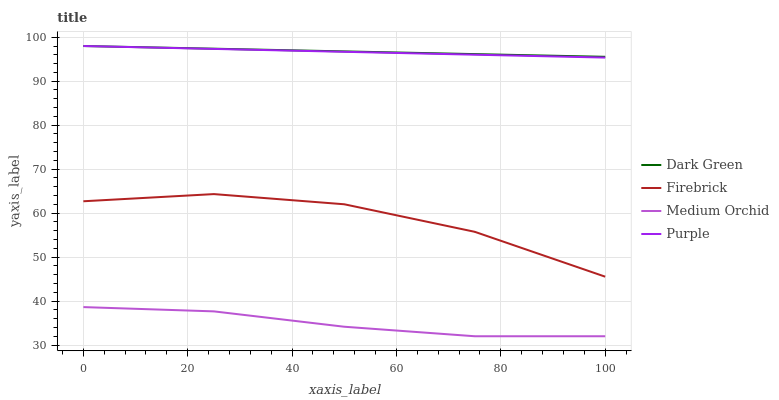Does Medium Orchid have the minimum area under the curve?
Answer yes or no. Yes. Does Dark Green have the maximum area under the curve?
Answer yes or no. Yes. Does Firebrick have the minimum area under the curve?
Answer yes or no. No. Does Firebrick have the maximum area under the curve?
Answer yes or no. No. Is Purple the smoothest?
Answer yes or no. Yes. Is Firebrick the roughest?
Answer yes or no. Yes. Is Medium Orchid the smoothest?
Answer yes or no. No. Is Medium Orchid the roughest?
Answer yes or no. No. Does Firebrick have the lowest value?
Answer yes or no. No. Does Dark Green have the highest value?
Answer yes or no. Yes. Does Firebrick have the highest value?
Answer yes or no. No. Is Medium Orchid less than Firebrick?
Answer yes or no. Yes. Is Purple greater than Medium Orchid?
Answer yes or no. Yes. Does Dark Green intersect Purple?
Answer yes or no. Yes. Is Dark Green less than Purple?
Answer yes or no. No. Is Dark Green greater than Purple?
Answer yes or no. No. Does Medium Orchid intersect Firebrick?
Answer yes or no. No. 